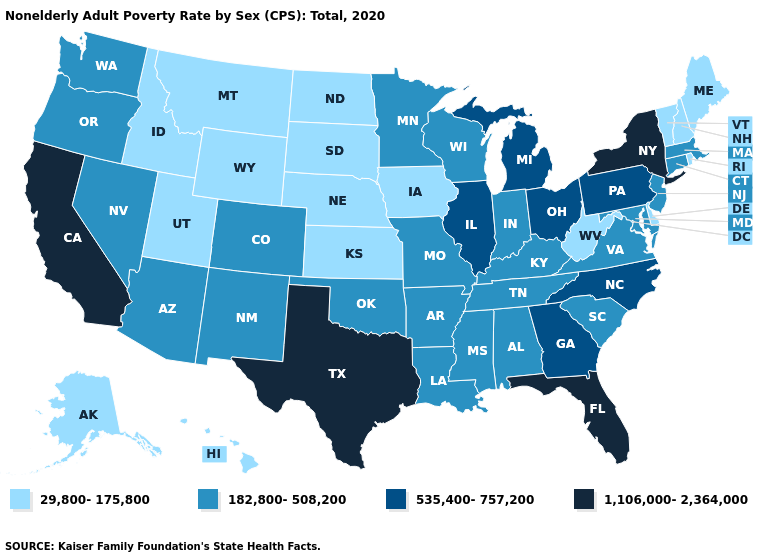What is the value of Washington?
Write a very short answer. 182,800-508,200. Name the states that have a value in the range 535,400-757,200?
Give a very brief answer. Georgia, Illinois, Michigan, North Carolina, Ohio, Pennsylvania. What is the value of Indiana?
Quick response, please. 182,800-508,200. Which states have the highest value in the USA?
Give a very brief answer. California, Florida, New York, Texas. Name the states that have a value in the range 1,106,000-2,364,000?
Concise answer only. California, Florida, New York, Texas. What is the highest value in the USA?
Quick response, please. 1,106,000-2,364,000. What is the highest value in the West ?
Quick response, please. 1,106,000-2,364,000. Name the states that have a value in the range 1,106,000-2,364,000?
Concise answer only. California, Florida, New York, Texas. Which states have the highest value in the USA?
Keep it brief. California, Florida, New York, Texas. What is the value of Massachusetts?
Concise answer only. 182,800-508,200. What is the value of Hawaii?
Be succinct. 29,800-175,800. Name the states that have a value in the range 29,800-175,800?
Answer briefly. Alaska, Delaware, Hawaii, Idaho, Iowa, Kansas, Maine, Montana, Nebraska, New Hampshire, North Dakota, Rhode Island, South Dakota, Utah, Vermont, West Virginia, Wyoming. What is the value of Iowa?
Quick response, please. 29,800-175,800. What is the value of West Virginia?
Keep it brief. 29,800-175,800. Which states have the lowest value in the USA?
Keep it brief. Alaska, Delaware, Hawaii, Idaho, Iowa, Kansas, Maine, Montana, Nebraska, New Hampshire, North Dakota, Rhode Island, South Dakota, Utah, Vermont, West Virginia, Wyoming. 